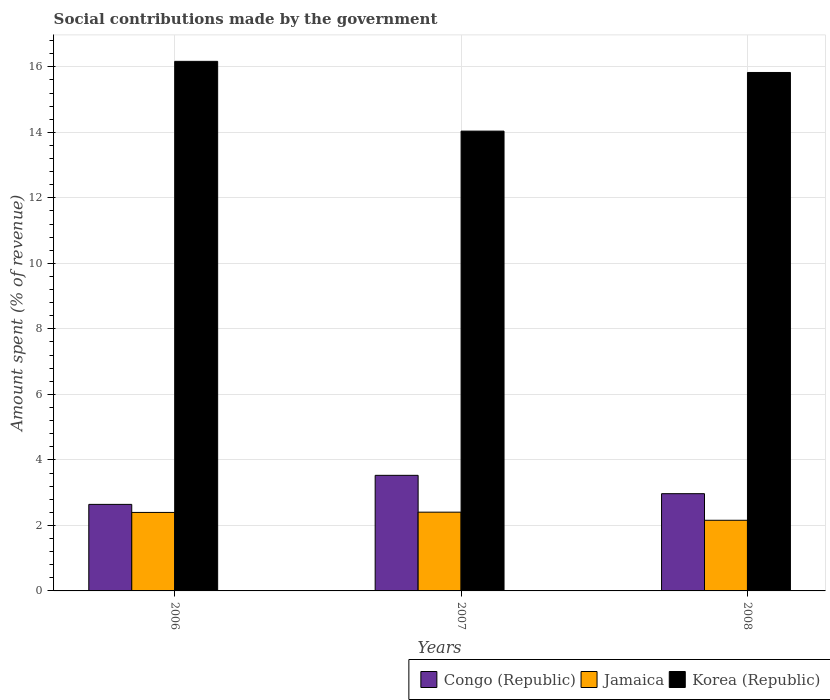How many different coloured bars are there?
Offer a very short reply. 3. How many groups of bars are there?
Offer a very short reply. 3. Are the number of bars per tick equal to the number of legend labels?
Your answer should be very brief. Yes. Are the number of bars on each tick of the X-axis equal?
Offer a terse response. Yes. How many bars are there on the 3rd tick from the right?
Your response must be concise. 3. What is the amount spent (in %) on social contributions in Congo (Republic) in 2006?
Make the answer very short. 2.64. Across all years, what is the maximum amount spent (in %) on social contributions in Jamaica?
Keep it short and to the point. 2.4. Across all years, what is the minimum amount spent (in %) on social contributions in Congo (Republic)?
Your answer should be compact. 2.64. In which year was the amount spent (in %) on social contributions in Congo (Republic) maximum?
Offer a terse response. 2007. What is the total amount spent (in %) on social contributions in Congo (Republic) in the graph?
Make the answer very short. 9.14. What is the difference between the amount spent (in %) on social contributions in Congo (Republic) in 2006 and that in 2007?
Provide a succinct answer. -0.89. What is the difference between the amount spent (in %) on social contributions in Jamaica in 2007 and the amount spent (in %) on social contributions in Congo (Republic) in 2006?
Provide a short and direct response. -0.24. What is the average amount spent (in %) on social contributions in Korea (Republic) per year?
Offer a very short reply. 15.34. In the year 2006, what is the difference between the amount spent (in %) on social contributions in Jamaica and amount spent (in %) on social contributions in Congo (Republic)?
Your response must be concise. -0.25. What is the ratio of the amount spent (in %) on social contributions in Korea (Republic) in 2006 to that in 2008?
Provide a succinct answer. 1.02. Is the difference between the amount spent (in %) on social contributions in Jamaica in 2006 and 2007 greater than the difference between the amount spent (in %) on social contributions in Congo (Republic) in 2006 and 2007?
Make the answer very short. Yes. What is the difference between the highest and the second highest amount spent (in %) on social contributions in Jamaica?
Give a very brief answer. 0.01. What is the difference between the highest and the lowest amount spent (in %) on social contributions in Congo (Republic)?
Provide a short and direct response. 0.89. In how many years, is the amount spent (in %) on social contributions in Korea (Republic) greater than the average amount spent (in %) on social contributions in Korea (Republic) taken over all years?
Provide a short and direct response. 2. Is the sum of the amount spent (in %) on social contributions in Korea (Republic) in 2007 and 2008 greater than the maximum amount spent (in %) on social contributions in Congo (Republic) across all years?
Your answer should be very brief. Yes. What does the 2nd bar from the left in 2008 represents?
Keep it short and to the point. Jamaica. What does the 2nd bar from the right in 2006 represents?
Provide a short and direct response. Jamaica. How many bars are there?
Make the answer very short. 9. How many years are there in the graph?
Your answer should be compact. 3. What is the difference between two consecutive major ticks on the Y-axis?
Provide a succinct answer. 2. Does the graph contain any zero values?
Provide a short and direct response. No. Does the graph contain grids?
Ensure brevity in your answer.  Yes. Where does the legend appear in the graph?
Your answer should be very brief. Bottom right. How many legend labels are there?
Keep it short and to the point. 3. How are the legend labels stacked?
Provide a succinct answer. Horizontal. What is the title of the graph?
Make the answer very short. Social contributions made by the government. Does "Tunisia" appear as one of the legend labels in the graph?
Your answer should be very brief. No. What is the label or title of the X-axis?
Make the answer very short. Years. What is the label or title of the Y-axis?
Offer a very short reply. Amount spent (% of revenue). What is the Amount spent (% of revenue) in Congo (Republic) in 2006?
Make the answer very short. 2.64. What is the Amount spent (% of revenue) in Jamaica in 2006?
Keep it short and to the point. 2.4. What is the Amount spent (% of revenue) in Korea (Republic) in 2006?
Offer a very short reply. 16.17. What is the Amount spent (% of revenue) in Congo (Republic) in 2007?
Your answer should be compact. 3.53. What is the Amount spent (% of revenue) of Jamaica in 2007?
Ensure brevity in your answer.  2.4. What is the Amount spent (% of revenue) in Korea (Republic) in 2007?
Keep it short and to the point. 14.04. What is the Amount spent (% of revenue) in Congo (Republic) in 2008?
Your response must be concise. 2.97. What is the Amount spent (% of revenue) in Jamaica in 2008?
Keep it short and to the point. 2.16. What is the Amount spent (% of revenue) of Korea (Republic) in 2008?
Offer a very short reply. 15.83. Across all years, what is the maximum Amount spent (% of revenue) in Congo (Republic)?
Provide a succinct answer. 3.53. Across all years, what is the maximum Amount spent (% of revenue) in Jamaica?
Your answer should be compact. 2.4. Across all years, what is the maximum Amount spent (% of revenue) in Korea (Republic)?
Your answer should be compact. 16.17. Across all years, what is the minimum Amount spent (% of revenue) in Congo (Republic)?
Ensure brevity in your answer.  2.64. Across all years, what is the minimum Amount spent (% of revenue) in Jamaica?
Your response must be concise. 2.16. Across all years, what is the minimum Amount spent (% of revenue) of Korea (Republic)?
Make the answer very short. 14.04. What is the total Amount spent (% of revenue) of Congo (Republic) in the graph?
Make the answer very short. 9.14. What is the total Amount spent (% of revenue) in Jamaica in the graph?
Your response must be concise. 6.96. What is the total Amount spent (% of revenue) of Korea (Republic) in the graph?
Provide a succinct answer. 46.03. What is the difference between the Amount spent (% of revenue) in Congo (Republic) in 2006 and that in 2007?
Provide a short and direct response. -0.89. What is the difference between the Amount spent (% of revenue) in Jamaica in 2006 and that in 2007?
Offer a terse response. -0.01. What is the difference between the Amount spent (% of revenue) of Korea (Republic) in 2006 and that in 2007?
Ensure brevity in your answer.  2.13. What is the difference between the Amount spent (% of revenue) in Congo (Republic) in 2006 and that in 2008?
Ensure brevity in your answer.  -0.33. What is the difference between the Amount spent (% of revenue) in Jamaica in 2006 and that in 2008?
Offer a terse response. 0.24. What is the difference between the Amount spent (% of revenue) in Korea (Republic) in 2006 and that in 2008?
Ensure brevity in your answer.  0.34. What is the difference between the Amount spent (% of revenue) in Congo (Republic) in 2007 and that in 2008?
Offer a very short reply. 0.56. What is the difference between the Amount spent (% of revenue) of Jamaica in 2007 and that in 2008?
Provide a succinct answer. 0.25. What is the difference between the Amount spent (% of revenue) of Korea (Republic) in 2007 and that in 2008?
Keep it short and to the point. -1.79. What is the difference between the Amount spent (% of revenue) in Congo (Republic) in 2006 and the Amount spent (% of revenue) in Jamaica in 2007?
Give a very brief answer. 0.24. What is the difference between the Amount spent (% of revenue) of Congo (Republic) in 2006 and the Amount spent (% of revenue) of Korea (Republic) in 2007?
Provide a short and direct response. -11.4. What is the difference between the Amount spent (% of revenue) in Jamaica in 2006 and the Amount spent (% of revenue) in Korea (Republic) in 2007?
Your answer should be very brief. -11.64. What is the difference between the Amount spent (% of revenue) in Congo (Republic) in 2006 and the Amount spent (% of revenue) in Jamaica in 2008?
Provide a succinct answer. 0.49. What is the difference between the Amount spent (% of revenue) of Congo (Republic) in 2006 and the Amount spent (% of revenue) of Korea (Republic) in 2008?
Your response must be concise. -13.19. What is the difference between the Amount spent (% of revenue) in Jamaica in 2006 and the Amount spent (% of revenue) in Korea (Republic) in 2008?
Offer a very short reply. -13.43. What is the difference between the Amount spent (% of revenue) of Congo (Republic) in 2007 and the Amount spent (% of revenue) of Jamaica in 2008?
Your answer should be compact. 1.37. What is the difference between the Amount spent (% of revenue) in Congo (Republic) in 2007 and the Amount spent (% of revenue) in Korea (Republic) in 2008?
Offer a very short reply. -12.3. What is the difference between the Amount spent (% of revenue) in Jamaica in 2007 and the Amount spent (% of revenue) in Korea (Republic) in 2008?
Provide a short and direct response. -13.42. What is the average Amount spent (% of revenue) of Congo (Republic) per year?
Make the answer very short. 3.05. What is the average Amount spent (% of revenue) of Jamaica per year?
Offer a very short reply. 2.32. What is the average Amount spent (% of revenue) of Korea (Republic) per year?
Your answer should be very brief. 15.34. In the year 2006, what is the difference between the Amount spent (% of revenue) of Congo (Republic) and Amount spent (% of revenue) of Jamaica?
Provide a short and direct response. 0.25. In the year 2006, what is the difference between the Amount spent (% of revenue) in Congo (Republic) and Amount spent (% of revenue) in Korea (Republic)?
Offer a very short reply. -13.53. In the year 2006, what is the difference between the Amount spent (% of revenue) of Jamaica and Amount spent (% of revenue) of Korea (Republic)?
Give a very brief answer. -13.77. In the year 2007, what is the difference between the Amount spent (% of revenue) in Congo (Republic) and Amount spent (% of revenue) in Jamaica?
Make the answer very short. 1.12. In the year 2007, what is the difference between the Amount spent (% of revenue) in Congo (Republic) and Amount spent (% of revenue) in Korea (Republic)?
Your answer should be very brief. -10.51. In the year 2007, what is the difference between the Amount spent (% of revenue) of Jamaica and Amount spent (% of revenue) of Korea (Republic)?
Offer a terse response. -11.63. In the year 2008, what is the difference between the Amount spent (% of revenue) of Congo (Republic) and Amount spent (% of revenue) of Jamaica?
Provide a short and direct response. 0.81. In the year 2008, what is the difference between the Amount spent (% of revenue) in Congo (Republic) and Amount spent (% of revenue) in Korea (Republic)?
Your response must be concise. -12.86. In the year 2008, what is the difference between the Amount spent (% of revenue) of Jamaica and Amount spent (% of revenue) of Korea (Republic)?
Offer a very short reply. -13.67. What is the ratio of the Amount spent (% of revenue) in Congo (Republic) in 2006 to that in 2007?
Your answer should be very brief. 0.75. What is the ratio of the Amount spent (% of revenue) in Korea (Republic) in 2006 to that in 2007?
Your answer should be compact. 1.15. What is the ratio of the Amount spent (% of revenue) of Congo (Republic) in 2006 to that in 2008?
Your answer should be very brief. 0.89. What is the ratio of the Amount spent (% of revenue) of Jamaica in 2006 to that in 2008?
Your answer should be very brief. 1.11. What is the ratio of the Amount spent (% of revenue) in Korea (Republic) in 2006 to that in 2008?
Your answer should be compact. 1.02. What is the ratio of the Amount spent (% of revenue) in Congo (Republic) in 2007 to that in 2008?
Provide a succinct answer. 1.19. What is the ratio of the Amount spent (% of revenue) in Jamaica in 2007 to that in 2008?
Give a very brief answer. 1.11. What is the ratio of the Amount spent (% of revenue) of Korea (Republic) in 2007 to that in 2008?
Ensure brevity in your answer.  0.89. What is the difference between the highest and the second highest Amount spent (% of revenue) of Congo (Republic)?
Offer a terse response. 0.56. What is the difference between the highest and the second highest Amount spent (% of revenue) of Jamaica?
Provide a short and direct response. 0.01. What is the difference between the highest and the second highest Amount spent (% of revenue) of Korea (Republic)?
Give a very brief answer. 0.34. What is the difference between the highest and the lowest Amount spent (% of revenue) in Congo (Republic)?
Provide a succinct answer. 0.89. What is the difference between the highest and the lowest Amount spent (% of revenue) in Jamaica?
Provide a succinct answer. 0.25. What is the difference between the highest and the lowest Amount spent (% of revenue) in Korea (Republic)?
Your response must be concise. 2.13. 